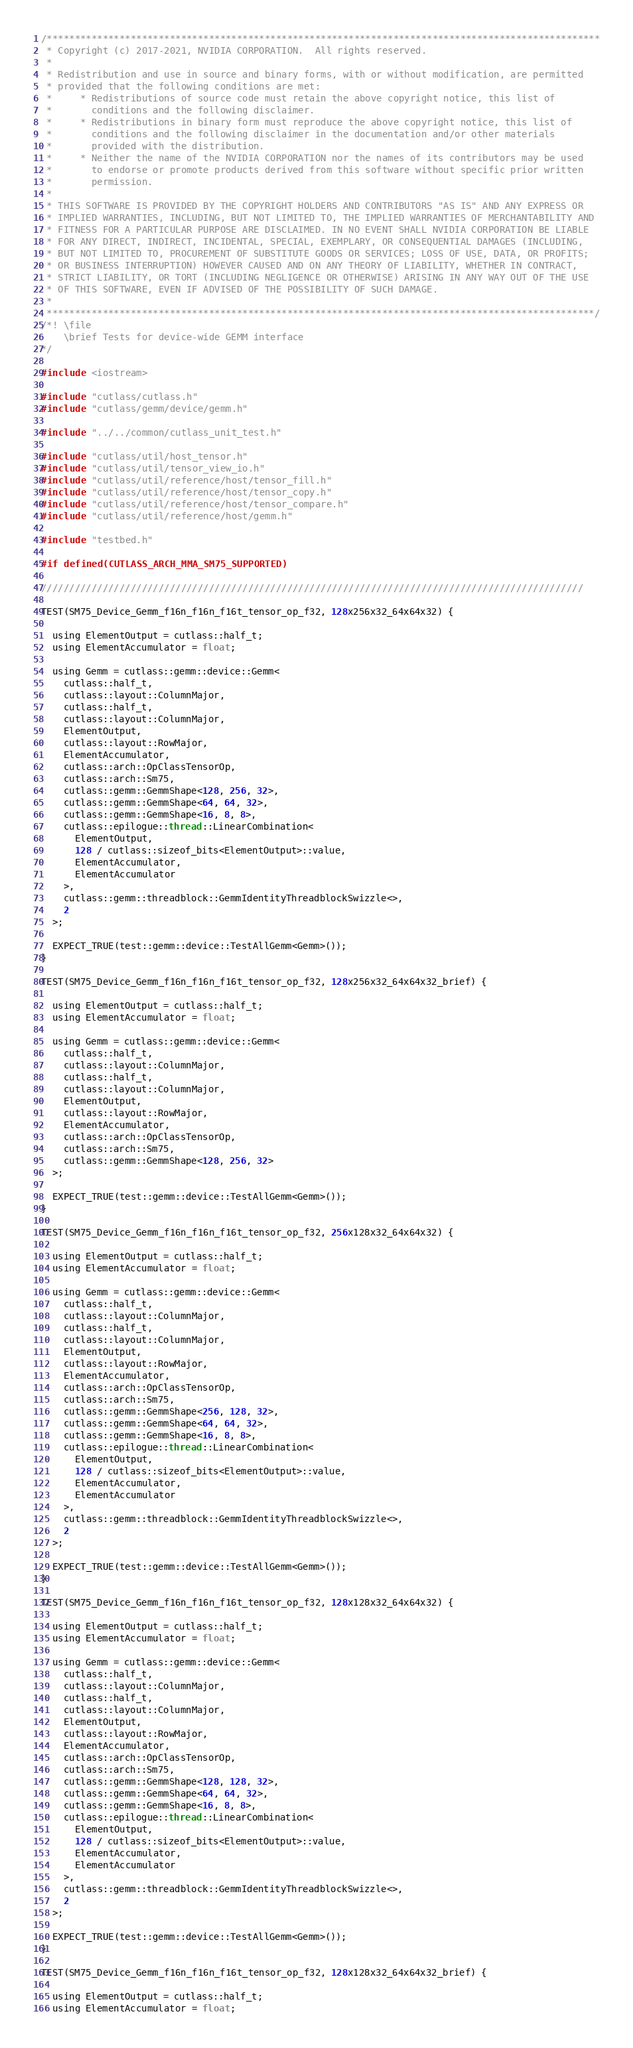Convert code to text. <code><loc_0><loc_0><loc_500><loc_500><_Cuda_>/***************************************************************************************************
 * Copyright (c) 2017-2021, NVIDIA CORPORATION.  All rights reserved.
 *
 * Redistribution and use in source and binary forms, with or without modification, are permitted
 * provided that the following conditions are met:
 *     * Redistributions of source code must retain the above copyright notice, this list of
 *       conditions and the following disclaimer.
 *     * Redistributions in binary form must reproduce the above copyright notice, this list of
 *       conditions and the following disclaimer in the documentation and/or other materials
 *       provided with the distribution.
 *     * Neither the name of the NVIDIA CORPORATION nor the names of its contributors may be used
 *       to endorse or promote products derived from this software without specific prior written
 *       permission.
 *
 * THIS SOFTWARE IS PROVIDED BY THE COPYRIGHT HOLDERS AND CONTRIBUTORS "AS IS" AND ANY EXPRESS OR
 * IMPLIED WARRANTIES, INCLUDING, BUT NOT LIMITED TO, THE IMPLIED WARRANTIES OF MERCHANTABILITY AND
 * FITNESS FOR A PARTICULAR PURPOSE ARE DISCLAIMED. IN NO EVENT SHALL NVIDIA CORPORATION BE LIABLE
 * FOR ANY DIRECT, INDIRECT, INCIDENTAL, SPECIAL, EXEMPLARY, OR CONSEQUENTIAL DAMAGES (INCLUDING,
 * BUT NOT LIMITED TO, PROCUREMENT OF SUBSTITUTE GOODS OR SERVICES; LOSS OF USE, DATA, OR PROFITS;
 * OR BUSINESS INTERRUPTION) HOWEVER CAUSED AND ON ANY THEORY OF LIABILITY, WHETHER IN CONTRACT,
 * STRICT LIABILITY, OR TORT (INCLUDING NEGLIGENCE OR OTHERWISE) ARISING IN ANY WAY OUT OF THE USE
 * OF THIS SOFTWARE, EVEN IF ADVISED OF THE POSSIBILITY OF SUCH DAMAGE.
 *
 **************************************************************************************************/
/*! \file
    \brief Tests for device-wide GEMM interface
*/

#include <iostream>

#include "cutlass/cutlass.h"
#include "cutlass/gemm/device/gemm.h"

#include "../../common/cutlass_unit_test.h"

#include "cutlass/util/host_tensor.h"
#include "cutlass/util/tensor_view_io.h"
#include "cutlass/util/reference/host/tensor_fill.h"
#include "cutlass/util/reference/host/tensor_copy.h"
#include "cutlass/util/reference/host/tensor_compare.h"
#include "cutlass/util/reference/host/gemm.h"

#include "testbed.h"

#if defined(CUTLASS_ARCH_MMA_SM75_SUPPORTED)

/////////////////////////////////////////////////////////////////////////////////////////////////

TEST(SM75_Device_Gemm_f16n_f16n_f16t_tensor_op_f32, 128x256x32_64x64x32) {

  using ElementOutput = cutlass::half_t;
  using ElementAccumulator = float;

  using Gemm = cutlass::gemm::device::Gemm<
    cutlass::half_t,
    cutlass::layout::ColumnMajor,
    cutlass::half_t,
    cutlass::layout::ColumnMajor,
    ElementOutput,
    cutlass::layout::RowMajor,
    ElementAccumulator,
    cutlass::arch::OpClassTensorOp,
    cutlass::arch::Sm75,
    cutlass::gemm::GemmShape<128, 256, 32>,
    cutlass::gemm::GemmShape<64, 64, 32>,
    cutlass::gemm::GemmShape<16, 8, 8>,
    cutlass::epilogue::thread::LinearCombination<
      ElementOutput,
      128 / cutlass::sizeof_bits<ElementOutput>::value,
      ElementAccumulator,
      ElementAccumulator
    >,
    cutlass::gemm::threadblock::GemmIdentityThreadblockSwizzle<>,
    2
  >;

  EXPECT_TRUE(test::gemm::device::TestAllGemm<Gemm>());
}

TEST(SM75_Device_Gemm_f16n_f16n_f16t_tensor_op_f32, 128x256x32_64x64x32_brief) {

  using ElementOutput = cutlass::half_t;
  using ElementAccumulator = float;

  using Gemm = cutlass::gemm::device::Gemm<
    cutlass::half_t,
    cutlass::layout::ColumnMajor,
    cutlass::half_t,
    cutlass::layout::ColumnMajor,
    ElementOutput,
    cutlass::layout::RowMajor,
    ElementAccumulator,
    cutlass::arch::OpClassTensorOp,
    cutlass::arch::Sm75,
    cutlass::gemm::GemmShape<128, 256, 32>
  >;

  EXPECT_TRUE(test::gemm::device::TestAllGemm<Gemm>());
}

TEST(SM75_Device_Gemm_f16n_f16n_f16t_tensor_op_f32, 256x128x32_64x64x32) {

  using ElementOutput = cutlass::half_t;
  using ElementAccumulator = float;

  using Gemm = cutlass::gemm::device::Gemm<
    cutlass::half_t,
    cutlass::layout::ColumnMajor,
    cutlass::half_t,
    cutlass::layout::ColumnMajor,
    ElementOutput,
    cutlass::layout::RowMajor,
    ElementAccumulator,
    cutlass::arch::OpClassTensorOp,
    cutlass::arch::Sm75,
    cutlass::gemm::GemmShape<256, 128, 32>,
    cutlass::gemm::GemmShape<64, 64, 32>,
    cutlass::gemm::GemmShape<16, 8, 8>,
    cutlass::epilogue::thread::LinearCombination<
      ElementOutput,
      128 / cutlass::sizeof_bits<ElementOutput>::value,
      ElementAccumulator,
      ElementAccumulator
    >,
    cutlass::gemm::threadblock::GemmIdentityThreadblockSwizzle<>,
    2
  >;

  EXPECT_TRUE(test::gemm::device::TestAllGemm<Gemm>());
}

TEST(SM75_Device_Gemm_f16n_f16n_f16t_tensor_op_f32, 128x128x32_64x64x32) {

  using ElementOutput = cutlass::half_t;
  using ElementAccumulator = float;

  using Gemm = cutlass::gemm::device::Gemm<
    cutlass::half_t,
    cutlass::layout::ColumnMajor,
    cutlass::half_t,
    cutlass::layout::ColumnMajor,
    ElementOutput,
    cutlass::layout::RowMajor,
    ElementAccumulator,
    cutlass::arch::OpClassTensorOp,
    cutlass::arch::Sm75,
    cutlass::gemm::GemmShape<128, 128, 32>,
    cutlass::gemm::GemmShape<64, 64, 32>,
    cutlass::gemm::GemmShape<16, 8, 8>,
    cutlass::epilogue::thread::LinearCombination<
      ElementOutput,
      128 / cutlass::sizeof_bits<ElementOutput>::value,
      ElementAccumulator,
      ElementAccumulator
    >,
    cutlass::gemm::threadblock::GemmIdentityThreadblockSwizzle<>,
    2
  >;

  EXPECT_TRUE(test::gemm::device::TestAllGemm<Gemm>());
}

TEST(SM75_Device_Gemm_f16n_f16n_f16t_tensor_op_f32, 128x128x32_64x64x32_brief) {

  using ElementOutput = cutlass::half_t;
  using ElementAccumulator = float;
</code> 